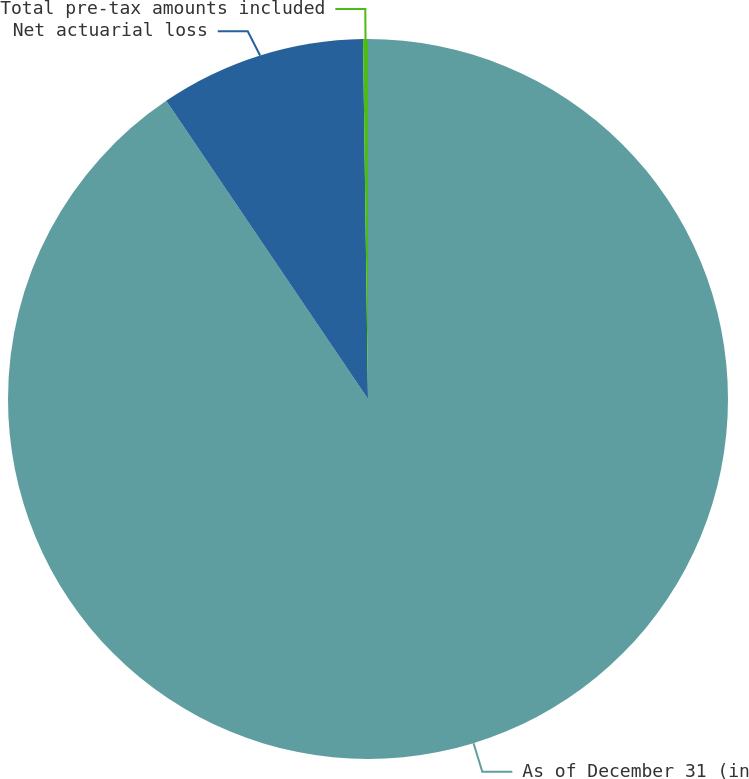Convert chart. <chart><loc_0><loc_0><loc_500><loc_500><pie_chart><fcel>As of December 31 (in<fcel>Net actuarial loss<fcel>Total pre-tax amounts included<nl><fcel>90.53%<fcel>9.25%<fcel>0.22%<nl></chart> 